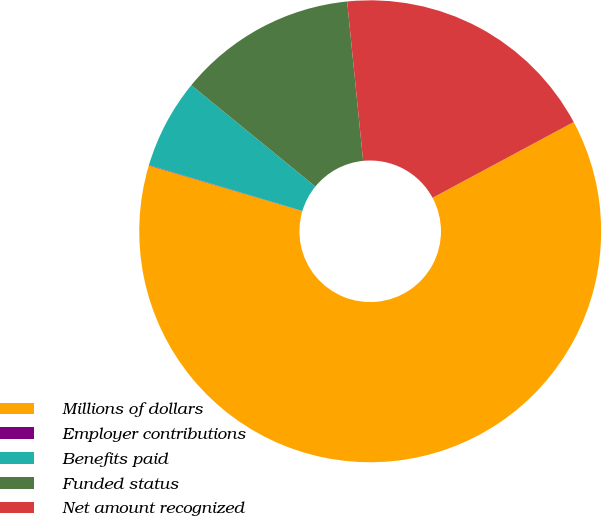Convert chart to OTSL. <chart><loc_0><loc_0><loc_500><loc_500><pie_chart><fcel>Millions of dollars<fcel>Employer contributions<fcel>Benefits paid<fcel>Funded status<fcel>Net amount recognized<nl><fcel>62.43%<fcel>0.03%<fcel>6.27%<fcel>12.51%<fcel>18.75%<nl></chart> 